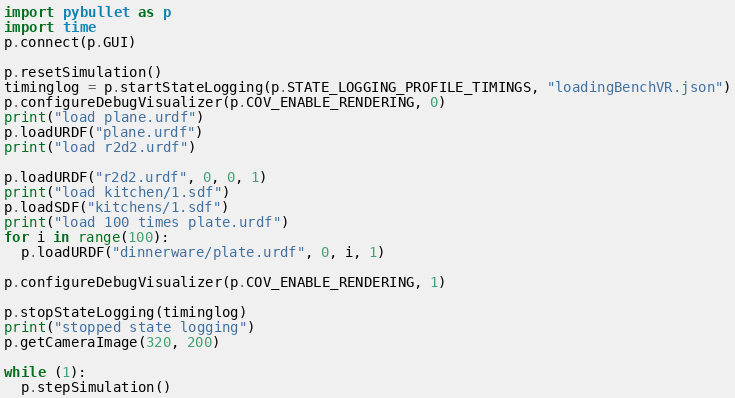<code> <loc_0><loc_0><loc_500><loc_500><_Python_>import pybullet as p
import time
p.connect(p.GUI)

p.resetSimulation()
timinglog = p.startStateLogging(p.STATE_LOGGING_PROFILE_TIMINGS, "loadingBenchVR.json")
p.configureDebugVisualizer(p.COV_ENABLE_RENDERING, 0)
print("load plane.urdf")
p.loadURDF("plane.urdf")
print("load r2d2.urdf")

p.loadURDF("r2d2.urdf", 0, 0, 1)
print("load kitchen/1.sdf")
p.loadSDF("kitchens/1.sdf")
print("load 100 times plate.urdf")
for i in range(100):
  p.loadURDF("dinnerware/plate.urdf", 0, i, 1)

p.configureDebugVisualizer(p.COV_ENABLE_RENDERING, 1)

p.stopStateLogging(timinglog)
print("stopped state logging")
p.getCameraImage(320, 200)

while (1):
  p.stepSimulation()
</code> 